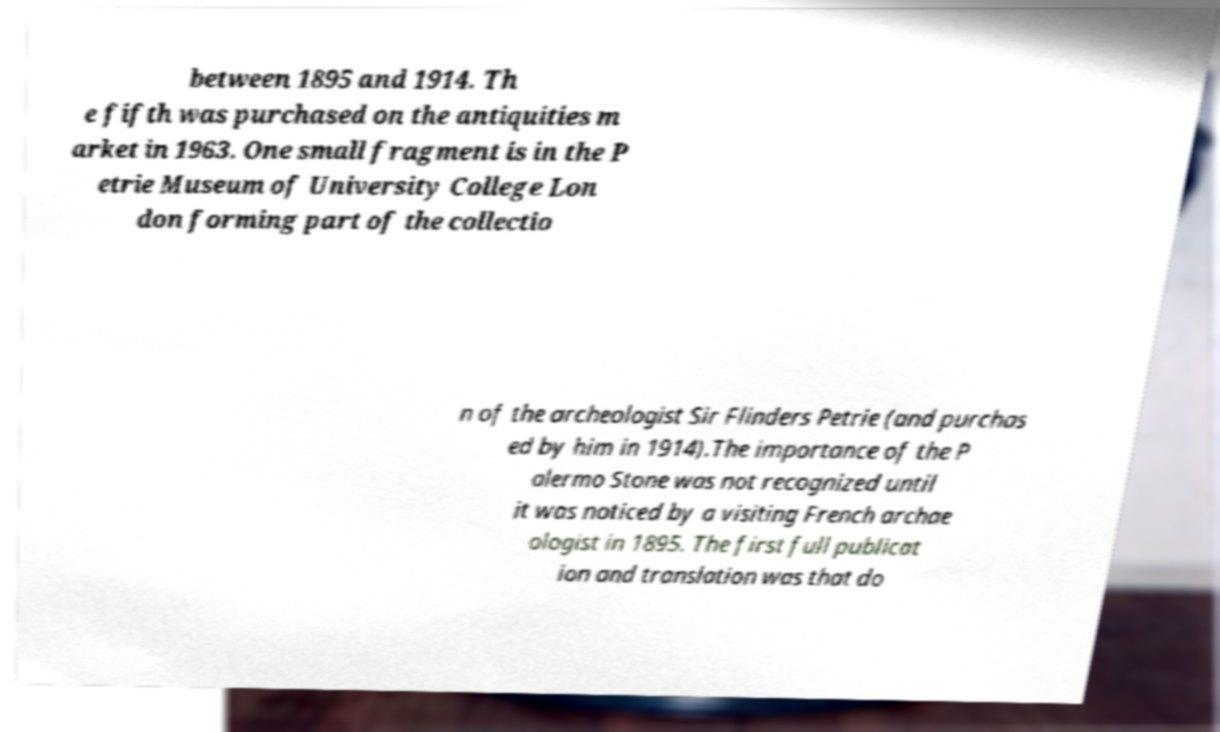For documentation purposes, I need the text within this image transcribed. Could you provide that? between 1895 and 1914. Th e fifth was purchased on the antiquities m arket in 1963. One small fragment is in the P etrie Museum of University College Lon don forming part of the collectio n of the archeologist Sir Flinders Petrie (and purchas ed by him in 1914).The importance of the P alermo Stone was not recognized until it was noticed by a visiting French archae ologist in 1895. The first full publicat ion and translation was that do 